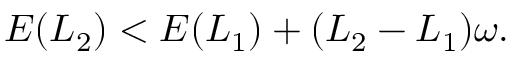<formula> <loc_0><loc_0><loc_500><loc_500>\begin{array} { r } { E ( L _ { 2 } ) < E ( L _ { 1 } ) + ( L _ { 2 } - L _ { 1 } ) \omega . } \end{array}</formula> 